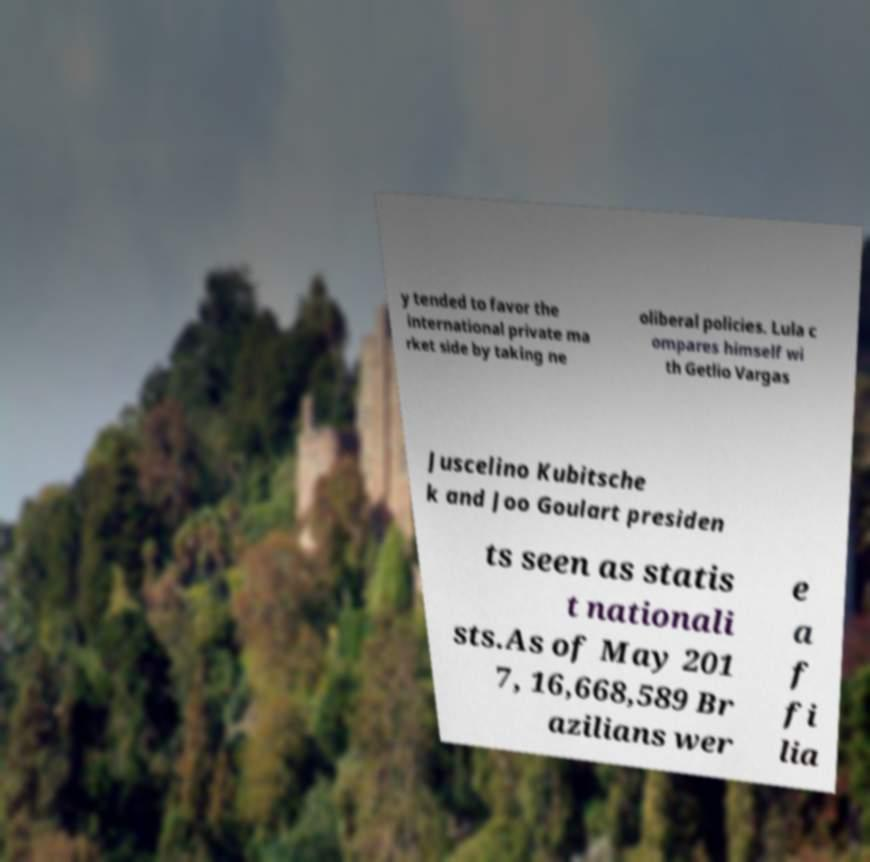Please read and relay the text visible in this image. What does it say? y tended to favor the international private ma rket side by taking ne oliberal policies. Lula c ompares himself wi th Getlio Vargas Juscelino Kubitsche k and Joo Goulart presiden ts seen as statis t nationali sts.As of May 201 7, 16,668,589 Br azilians wer e a f fi lia 